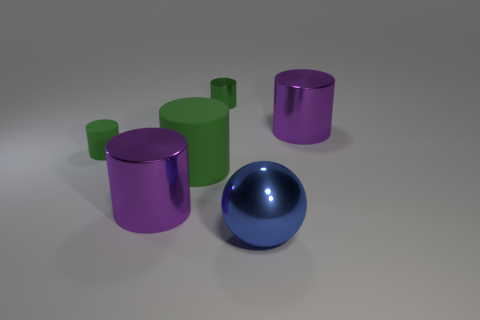Subtract all green cylinders. How many were subtracted if there are1green cylinders left? 2 Subtract all cyan spheres. How many green cylinders are left? 3 Subtract 1 cylinders. How many cylinders are left? 4 Subtract all small metal cylinders. How many cylinders are left? 4 Subtract all yellow cylinders. Subtract all purple blocks. How many cylinders are left? 5 Add 3 large spheres. How many objects exist? 9 Subtract all cylinders. How many objects are left? 1 Subtract 0 cyan cubes. How many objects are left? 6 Subtract all big metal cylinders. Subtract all metal balls. How many objects are left? 3 Add 4 metallic spheres. How many metallic spheres are left? 5 